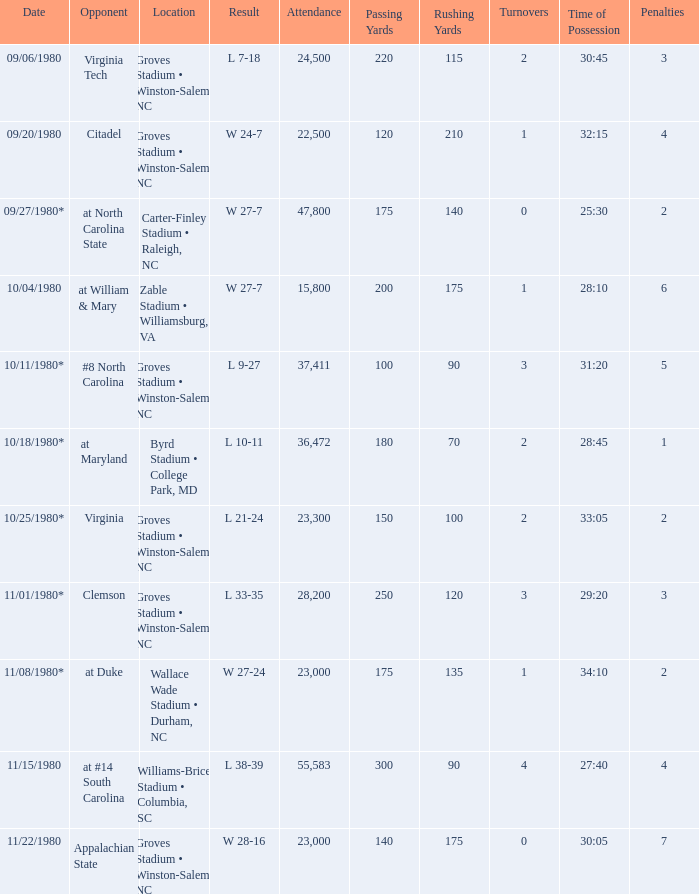How many people attended when Wake Forest played Virginia Tech? 24500.0. 